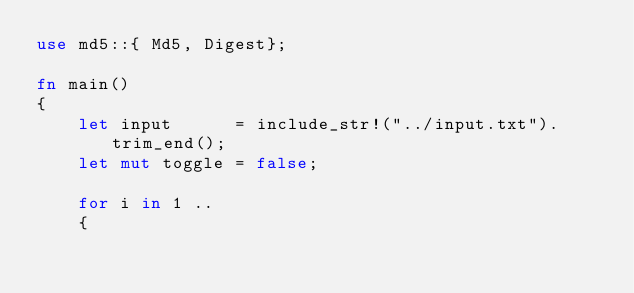<code> <loc_0><loc_0><loc_500><loc_500><_Rust_>use md5::{ Md5, Digest};

fn main()
{
    let input      = include_str!("../input.txt").trim_end();
    let mut toggle = false;

    for i in 1 ..
    {</code> 